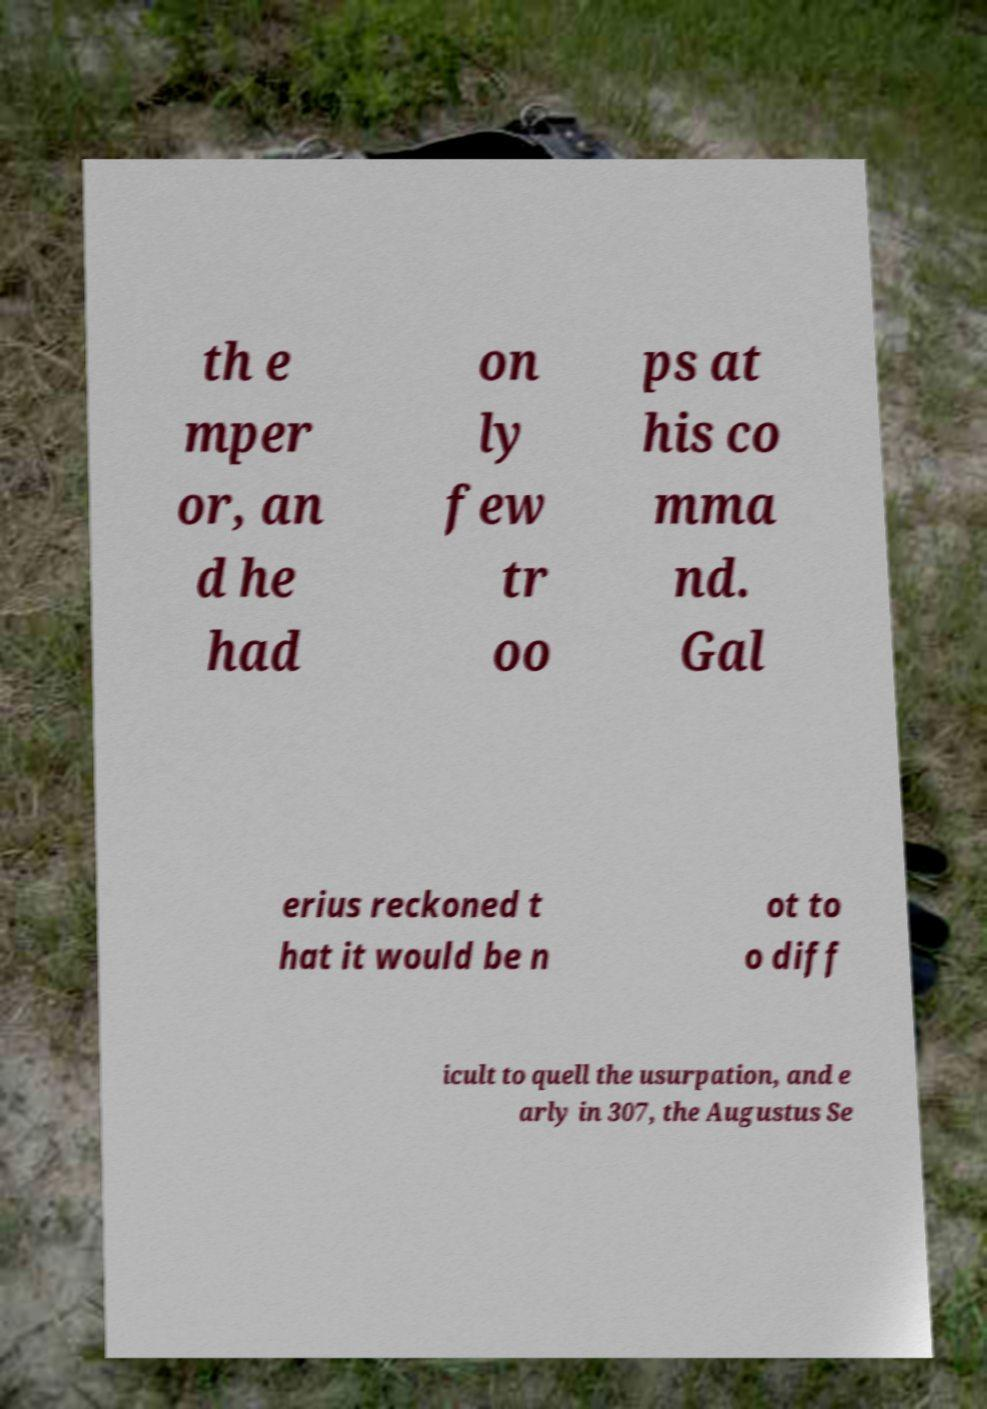For documentation purposes, I need the text within this image transcribed. Could you provide that? th e mper or, an d he had on ly few tr oo ps at his co mma nd. Gal erius reckoned t hat it would be n ot to o diff icult to quell the usurpation, and e arly in 307, the Augustus Se 